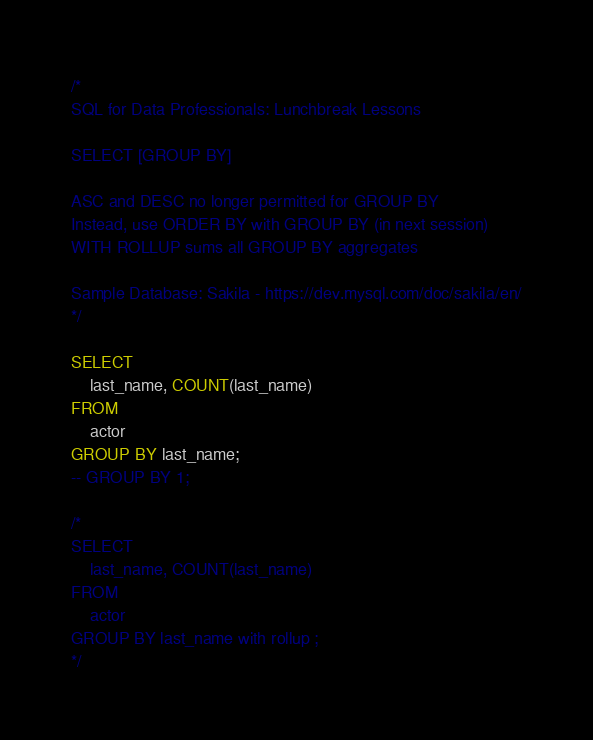Convert code to text. <code><loc_0><loc_0><loc_500><loc_500><_SQL_>/*
SQL for Data Professionals: Lunchbreak Lessons

SELECT [GROUP BY]

ASC and DESC no longer permitted for GROUP BY
Instead, use ORDER BY with GROUP BY (in next session)
WITH ROLLUP sums all GROUP BY aggregates

Sample Database: Sakila - https://dev.mysql.com/doc/sakila/en/
*/

SELECT 
    last_name, COUNT(last_name)
FROM
    actor
GROUP BY last_name;
-- GROUP BY 1;

/* 
SELECT 
    last_name, COUNT(last_name)
FROM
    actor
GROUP BY last_name with rollup ;
*/</code> 